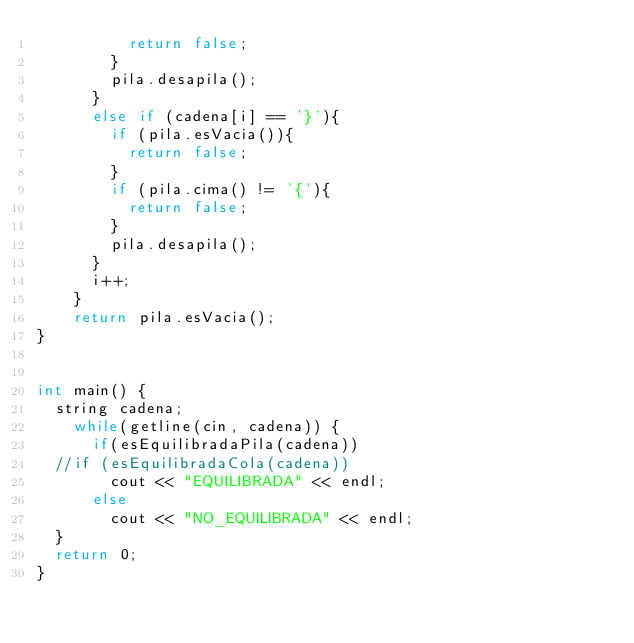Convert code to text. <code><loc_0><loc_0><loc_500><loc_500><_C++_>					return false;
				}
				pila.desapila();
			}
			else if (cadena[i] == '}'){
				if (pila.esVacia()){
					return false;
				}
				if (pila.cima() != '{'){
					return false;
				}
				pila.desapila();
			}
			i++;
		}
		return pila.esVacia();
}


int main() {
	string cadena;
    while(getline(cin, cadena)) {
      if(esEquilibradaPila(cadena))
	//if (esEquilibradaCola(cadena))
        cout << "EQUILIBRADA" << endl;
      else
        cout << "NO_EQUILIBRADA" << endl;		  
	}
	return 0;
}	
</code> 